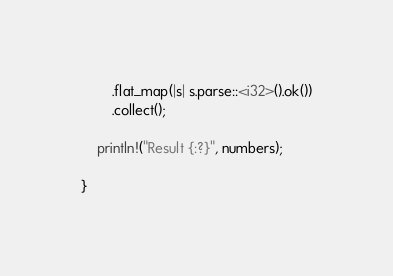<code> <loc_0><loc_0><loc_500><loc_500><_Rust_>        .flat_map(|s| s.parse::<i32>().ok())
        .collect();

    println!("Result {:?}", numbers);

}</code> 